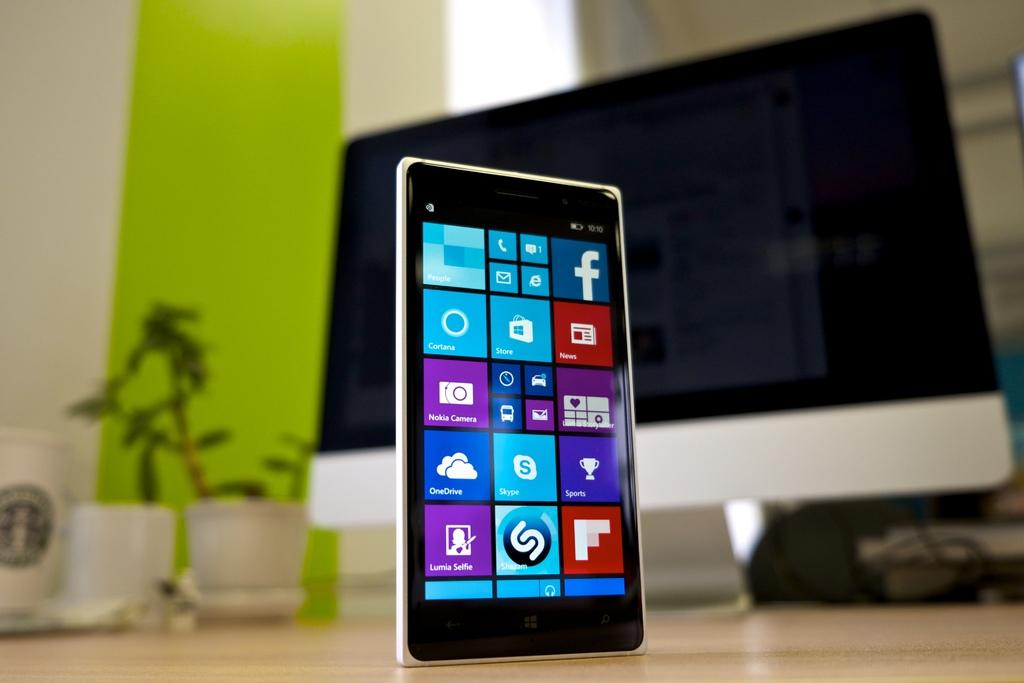<image>
Write a terse but informative summary of the picture. An app screen on a phone showing programs like Skype and Facebook 